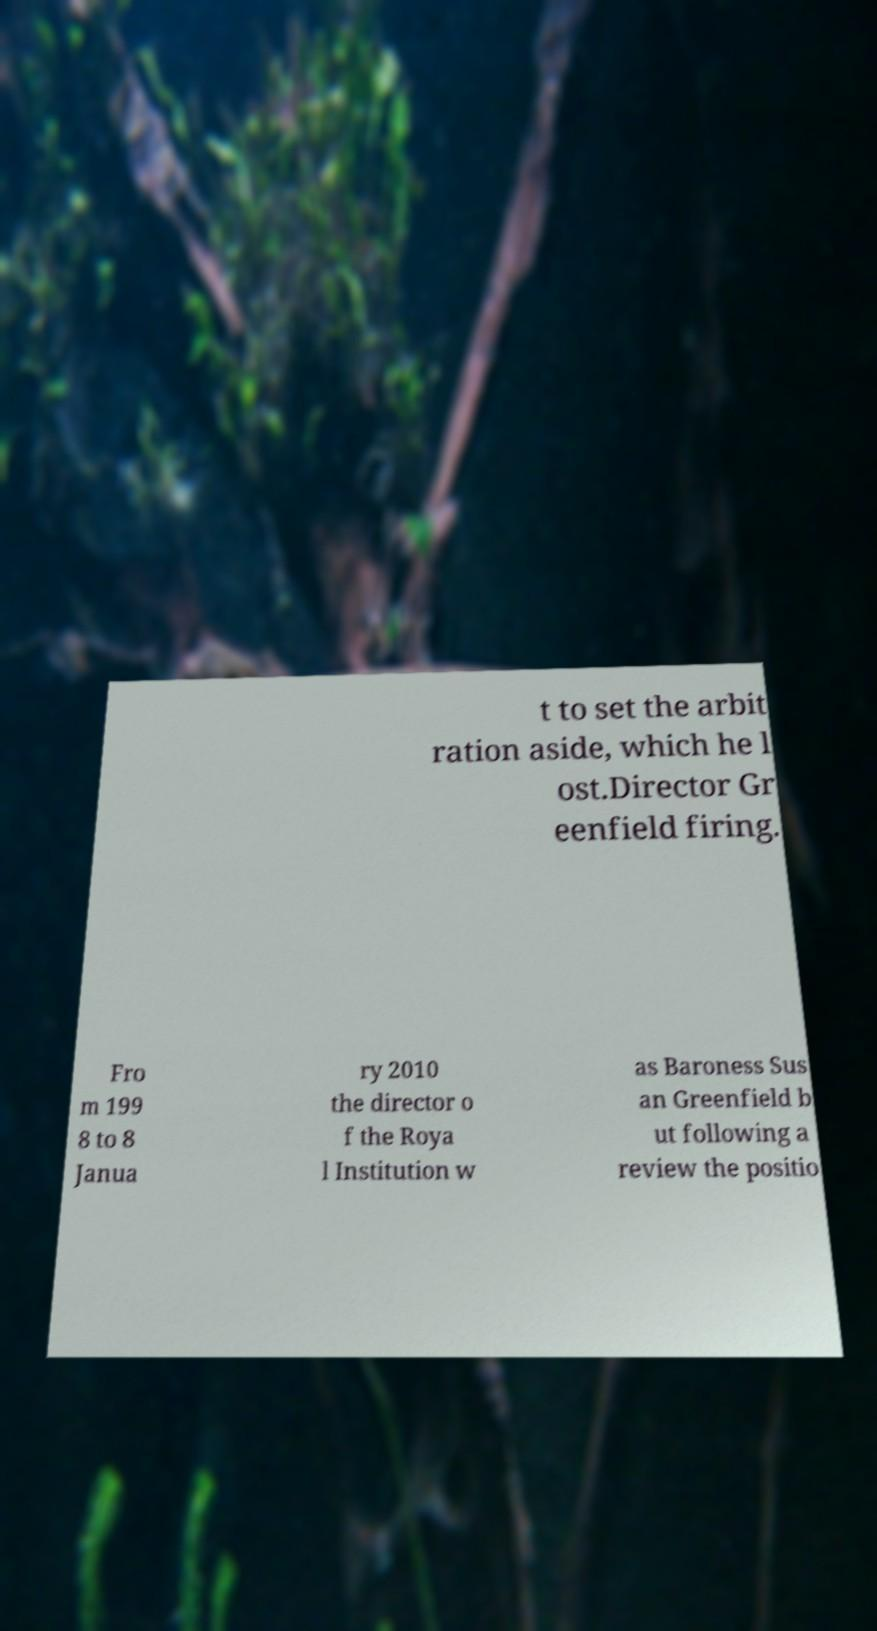Can you accurately transcribe the text from the provided image for me? t to set the arbit ration aside, which he l ost.Director Gr eenfield firing. Fro m 199 8 to 8 Janua ry 2010 the director o f the Roya l Institution w as Baroness Sus an Greenfield b ut following a review the positio 